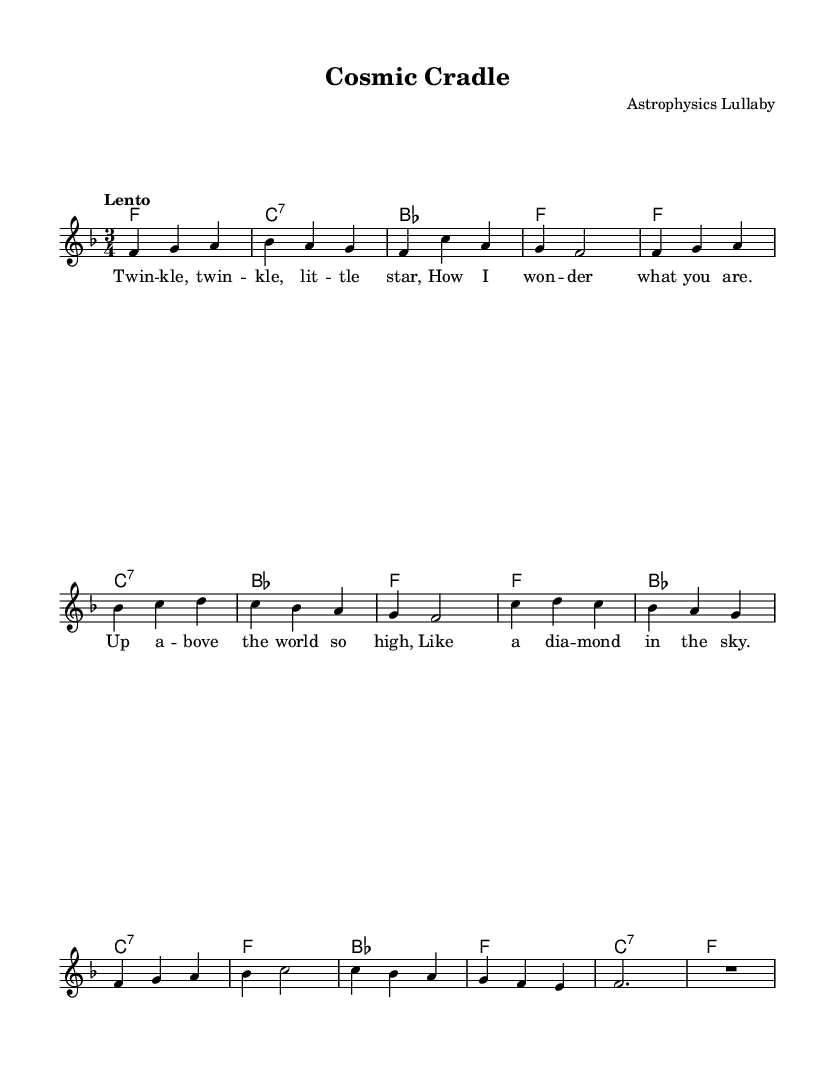What is the key signature of this music? The key signature shown in the global section indicates F major, which has one flat (B flat).
Answer: F major What is the time signature of the piece? The time signature is indicated as 3/4, meaning there are three beats in each measure.
Answer: 3/4 What is the tempo marking for this piece? The tempo marking states "Lento," which indicates a slow tempo.
Answer: Lento How many measures are in the melody? By counting the measures in the melody section, there are 8 measures total.
Answer: 8 What is the first note of the melody? The melody starts with the note F, as indicated at the beginning of the relative pitch notation.
Answer: F Identify the longest note value in the melody. The melody contains a half note, with a value of two beats, making it the longest note present.
Answer: Half note What atmospheric theme does this lullaby evoke? The lyrics refer specifically to a star, evoking a cosmic or celestial theme suitable for a gentle lullaby.
Answer: Cosmic 